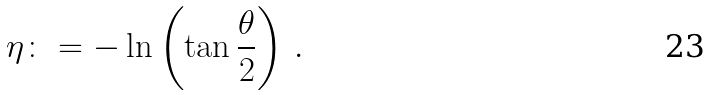Convert formula to latex. <formula><loc_0><loc_0><loc_500><loc_500>\eta \colon = - \ln \left ( \tan \frac { \theta } { 2 } \right ) \, .</formula> 